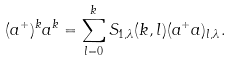Convert formula to latex. <formula><loc_0><loc_0><loc_500><loc_500>( a ^ { + } ) ^ { k } a ^ { k } = \sum _ { l = 0 } ^ { k } S _ { 1 , \lambda } ( k , l ) ( a ^ { + } a ) _ { l , \lambda } .</formula> 